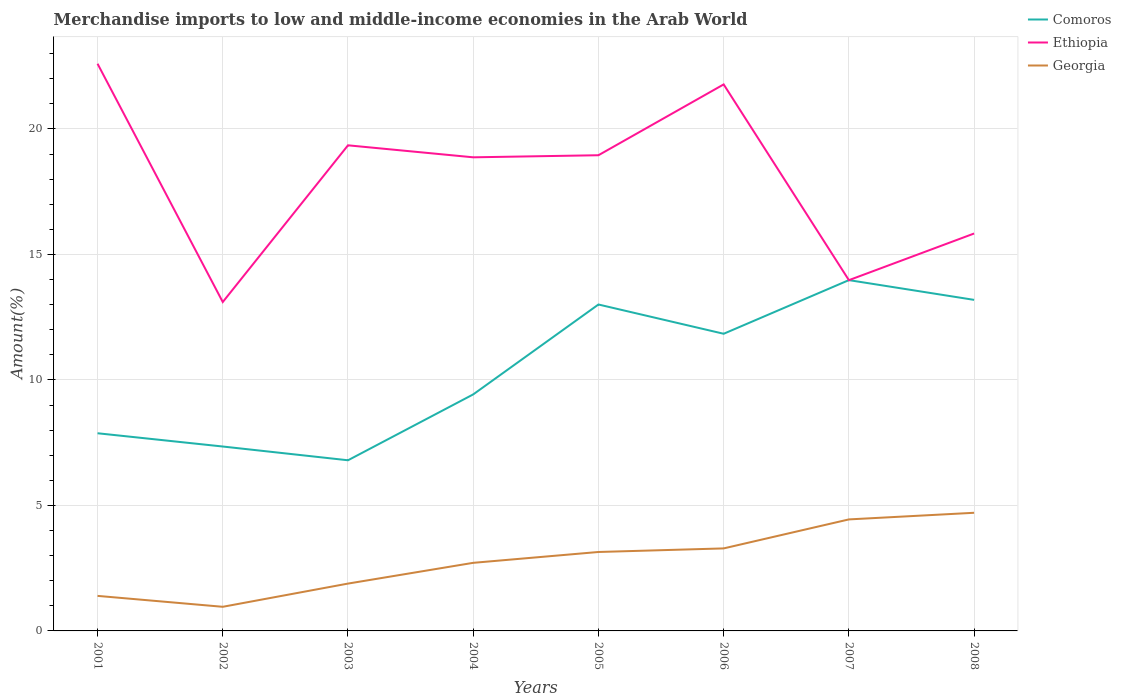How many different coloured lines are there?
Provide a succinct answer. 3. Does the line corresponding to Ethiopia intersect with the line corresponding to Comoros?
Your answer should be very brief. Yes. Across all years, what is the maximum percentage of amount earned from merchandise imports in Comoros?
Your answer should be compact. 6.8. In which year was the percentage of amount earned from merchandise imports in Ethiopia maximum?
Your answer should be very brief. 2002. What is the total percentage of amount earned from merchandise imports in Comoros in the graph?
Your response must be concise. -5.13. What is the difference between the highest and the second highest percentage of amount earned from merchandise imports in Ethiopia?
Keep it short and to the point. 9.49. What is the difference between the highest and the lowest percentage of amount earned from merchandise imports in Comoros?
Your response must be concise. 4. Is the percentage of amount earned from merchandise imports in Ethiopia strictly greater than the percentage of amount earned from merchandise imports in Georgia over the years?
Offer a terse response. No. Are the values on the major ticks of Y-axis written in scientific E-notation?
Your answer should be compact. No. Does the graph contain any zero values?
Your answer should be very brief. No. How many legend labels are there?
Your answer should be compact. 3. How are the legend labels stacked?
Offer a terse response. Vertical. What is the title of the graph?
Offer a terse response. Merchandise imports to low and middle-income economies in the Arab World. Does "Antigua and Barbuda" appear as one of the legend labels in the graph?
Provide a succinct answer. No. What is the label or title of the Y-axis?
Your answer should be compact. Amount(%). What is the Amount(%) of Comoros in 2001?
Your answer should be compact. 7.88. What is the Amount(%) in Ethiopia in 2001?
Give a very brief answer. 22.6. What is the Amount(%) in Georgia in 2001?
Ensure brevity in your answer.  1.4. What is the Amount(%) in Comoros in 2002?
Your answer should be very brief. 7.35. What is the Amount(%) of Ethiopia in 2002?
Give a very brief answer. 13.1. What is the Amount(%) in Georgia in 2002?
Your answer should be compact. 0.96. What is the Amount(%) of Comoros in 2003?
Keep it short and to the point. 6.8. What is the Amount(%) of Ethiopia in 2003?
Your answer should be very brief. 19.35. What is the Amount(%) of Georgia in 2003?
Offer a very short reply. 1.89. What is the Amount(%) in Comoros in 2004?
Keep it short and to the point. 9.42. What is the Amount(%) in Ethiopia in 2004?
Offer a terse response. 18.87. What is the Amount(%) in Georgia in 2004?
Keep it short and to the point. 2.71. What is the Amount(%) of Comoros in 2005?
Offer a very short reply. 13.01. What is the Amount(%) of Ethiopia in 2005?
Your answer should be very brief. 18.95. What is the Amount(%) in Georgia in 2005?
Offer a terse response. 3.15. What is the Amount(%) of Comoros in 2006?
Make the answer very short. 11.84. What is the Amount(%) in Ethiopia in 2006?
Your answer should be compact. 21.77. What is the Amount(%) of Georgia in 2006?
Provide a short and direct response. 3.29. What is the Amount(%) of Comoros in 2007?
Provide a short and direct response. 13.98. What is the Amount(%) in Ethiopia in 2007?
Your answer should be very brief. 13.98. What is the Amount(%) in Georgia in 2007?
Your response must be concise. 4.44. What is the Amount(%) of Comoros in 2008?
Provide a succinct answer. 13.19. What is the Amount(%) in Ethiopia in 2008?
Ensure brevity in your answer.  15.83. What is the Amount(%) of Georgia in 2008?
Offer a terse response. 4.71. Across all years, what is the maximum Amount(%) in Comoros?
Offer a terse response. 13.98. Across all years, what is the maximum Amount(%) in Ethiopia?
Your answer should be very brief. 22.6. Across all years, what is the maximum Amount(%) in Georgia?
Provide a succinct answer. 4.71. Across all years, what is the minimum Amount(%) of Comoros?
Make the answer very short. 6.8. Across all years, what is the minimum Amount(%) of Ethiopia?
Your response must be concise. 13.1. Across all years, what is the minimum Amount(%) of Georgia?
Your response must be concise. 0.96. What is the total Amount(%) in Comoros in the graph?
Provide a succinct answer. 83.46. What is the total Amount(%) in Ethiopia in the graph?
Provide a short and direct response. 144.46. What is the total Amount(%) in Georgia in the graph?
Your answer should be very brief. 22.54. What is the difference between the Amount(%) in Comoros in 2001 and that in 2002?
Ensure brevity in your answer.  0.53. What is the difference between the Amount(%) in Ethiopia in 2001 and that in 2002?
Give a very brief answer. 9.49. What is the difference between the Amount(%) of Georgia in 2001 and that in 2002?
Provide a short and direct response. 0.43. What is the difference between the Amount(%) in Comoros in 2001 and that in 2003?
Make the answer very short. 1.08. What is the difference between the Amount(%) of Ethiopia in 2001 and that in 2003?
Provide a short and direct response. 3.25. What is the difference between the Amount(%) in Georgia in 2001 and that in 2003?
Make the answer very short. -0.49. What is the difference between the Amount(%) in Comoros in 2001 and that in 2004?
Offer a terse response. -1.55. What is the difference between the Amount(%) in Ethiopia in 2001 and that in 2004?
Ensure brevity in your answer.  3.73. What is the difference between the Amount(%) of Georgia in 2001 and that in 2004?
Provide a short and direct response. -1.32. What is the difference between the Amount(%) of Comoros in 2001 and that in 2005?
Make the answer very short. -5.13. What is the difference between the Amount(%) in Ethiopia in 2001 and that in 2005?
Offer a terse response. 3.65. What is the difference between the Amount(%) in Georgia in 2001 and that in 2005?
Your response must be concise. -1.75. What is the difference between the Amount(%) of Comoros in 2001 and that in 2006?
Keep it short and to the point. -3.96. What is the difference between the Amount(%) of Ethiopia in 2001 and that in 2006?
Give a very brief answer. 0.82. What is the difference between the Amount(%) of Georgia in 2001 and that in 2006?
Make the answer very short. -1.89. What is the difference between the Amount(%) in Comoros in 2001 and that in 2007?
Your answer should be very brief. -6.1. What is the difference between the Amount(%) of Ethiopia in 2001 and that in 2007?
Ensure brevity in your answer.  8.62. What is the difference between the Amount(%) in Georgia in 2001 and that in 2007?
Ensure brevity in your answer.  -3.05. What is the difference between the Amount(%) in Comoros in 2001 and that in 2008?
Give a very brief answer. -5.31. What is the difference between the Amount(%) of Ethiopia in 2001 and that in 2008?
Your answer should be compact. 6.76. What is the difference between the Amount(%) in Georgia in 2001 and that in 2008?
Give a very brief answer. -3.31. What is the difference between the Amount(%) of Comoros in 2002 and that in 2003?
Keep it short and to the point. 0.55. What is the difference between the Amount(%) of Ethiopia in 2002 and that in 2003?
Your response must be concise. -6.24. What is the difference between the Amount(%) in Georgia in 2002 and that in 2003?
Provide a short and direct response. -0.93. What is the difference between the Amount(%) of Comoros in 2002 and that in 2004?
Provide a short and direct response. -2.08. What is the difference between the Amount(%) in Ethiopia in 2002 and that in 2004?
Give a very brief answer. -5.77. What is the difference between the Amount(%) in Georgia in 2002 and that in 2004?
Your response must be concise. -1.75. What is the difference between the Amount(%) in Comoros in 2002 and that in 2005?
Give a very brief answer. -5.66. What is the difference between the Amount(%) in Ethiopia in 2002 and that in 2005?
Offer a very short reply. -5.85. What is the difference between the Amount(%) in Georgia in 2002 and that in 2005?
Keep it short and to the point. -2.18. What is the difference between the Amount(%) of Comoros in 2002 and that in 2006?
Your response must be concise. -4.49. What is the difference between the Amount(%) of Ethiopia in 2002 and that in 2006?
Ensure brevity in your answer.  -8.67. What is the difference between the Amount(%) in Georgia in 2002 and that in 2006?
Offer a very short reply. -2.33. What is the difference between the Amount(%) of Comoros in 2002 and that in 2007?
Ensure brevity in your answer.  -6.63. What is the difference between the Amount(%) in Ethiopia in 2002 and that in 2007?
Make the answer very short. -0.87. What is the difference between the Amount(%) of Georgia in 2002 and that in 2007?
Offer a terse response. -3.48. What is the difference between the Amount(%) of Comoros in 2002 and that in 2008?
Provide a short and direct response. -5.84. What is the difference between the Amount(%) in Ethiopia in 2002 and that in 2008?
Offer a very short reply. -2.73. What is the difference between the Amount(%) in Georgia in 2002 and that in 2008?
Offer a terse response. -3.75. What is the difference between the Amount(%) of Comoros in 2003 and that in 2004?
Ensure brevity in your answer.  -2.62. What is the difference between the Amount(%) of Ethiopia in 2003 and that in 2004?
Your answer should be very brief. 0.48. What is the difference between the Amount(%) of Georgia in 2003 and that in 2004?
Keep it short and to the point. -0.83. What is the difference between the Amount(%) of Comoros in 2003 and that in 2005?
Provide a succinct answer. -6.21. What is the difference between the Amount(%) of Ethiopia in 2003 and that in 2005?
Offer a very short reply. 0.4. What is the difference between the Amount(%) of Georgia in 2003 and that in 2005?
Keep it short and to the point. -1.26. What is the difference between the Amount(%) of Comoros in 2003 and that in 2006?
Provide a short and direct response. -5.04. What is the difference between the Amount(%) in Ethiopia in 2003 and that in 2006?
Make the answer very short. -2.43. What is the difference between the Amount(%) in Georgia in 2003 and that in 2006?
Provide a short and direct response. -1.4. What is the difference between the Amount(%) in Comoros in 2003 and that in 2007?
Provide a succinct answer. -7.18. What is the difference between the Amount(%) in Ethiopia in 2003 and that in 2007?
Offer a terse response. 5.37. What is the difference between the Amount(%) in Georgia in 2003 and that in 2007?
Your answer should be very brief. -2.56. What is the difference between the Amount(%) of Comoros in 2003 and that in 2008?
Your response must be concise. -6.39. What is the difference between the Amount(%) of Ethiopia in 2003 and that in 2008?
Provide a short and direct response. 3.51. What is the difference between the Amount(%) of Georgia in 2003 and that in 2008?
Provide a succinct answer. -2.82. What is the difference between the Amount(%) in Comoros in 2004 and that in 2005?
Offer a very short reply. -3.58. What is the difference between the Amount(%) of Ethiopia in 2004 and that in 2005?
Make the answer very short. -0.08. What is the difference between the Amount(%) of Georgia in 2004 and that in 2005?
Ensure brevity in your answer.  -0.43. What is the difference between the Amount(%) of Comoros in 2004 and that in 2006?
Ensure brevity in your answer.  -2.42. What is the difference between the Amount(%) in Ethiopia in 2004 and that in 2006?
Your answer should be compact. -2.9. What is the difference between the Amount(%) of Georgia in 2004 and that in 2006?
Offer a very short reply. -0.57. What is the difference between the Amount(%) of Comoros in 2004 and that in 2007?
Provide a succinct answer. -4.55. What is the difference between the Amount(%) in Ethiopia in 2004 and that in 2007?
Provide a succinct answer. 4.89. What is the difference between the Amount(%) of Georgia in 2004 and that in 2007?
Give a very brief answer. -1.73. What is the difference between the Amount(%) of Comoros in 2004 and that in 2008?
Your answer should be very brief. -3.77. What is the difference between the Amount(%) in Ethiopia in 2004 and that in 2008?
Offer a very short reply. 3.04. What is the difference between the Amount(%) in Georgia in 2004 and that in 2008?
Your answer should be very brief. -1.99. What is the difference between the Amount(%) in Comoros in 2005 and that in 2006?
Provide a succinct answer. 1.17. What is the difference between the Amount(%) of Ethiopia in 2005 and that in 2006?
Your response must be concise. -2.82. What is the difference between the Amount(%) of Georgia in 2005 and that in 2006?
Your answer should be compact. -0.14. What is the difference between the Amount(%) in Comoros in 2005 and that in 2007?
Offer a terse response. -0.97. What is the difference between the Amount(%) in Ethiopia in 2005 and that in 2007?
Ensure brevity in your answer.  4.98. What is the difference between the Amount(%) in Georgia in 2005 and that in 2007?
Provide a short and direct response. -1.3. What is the difference between the Amount(%) of Comoros in 2005 and that in 2008?
Make the answer very short. -0.18. What is the difference between the Amount(%) of Ethiopia in 2005 and that in 2008?
Provide a short and direct response. 3.12. What is the difference between the Amount(%) of Georgia in 2005 and that in 2008?
Give a very brief answer. -1.56. What is the difference between the Amount(%) in Comoros in 2006 and that in 2007?
Keep it short and to the point. -2.14. What is the difference between the Amount(%) in Ethiopia in 2006 and that in 2007?
Offer a very short reply. 7.8. What is the difference between the Amount(%) of Georgia in 2006 and that in 2007?
Provide a short and direct response. -1.16. What is the difference between the Amount(%) of Comoros in 2006 and that in 2008?
Your answer should be compact. -1.35. What is the difference between the Amount(%) of Ethiopia in 2006 and that in 2008?
Your answer should be very brief. 5.94. What is the difference between the Amount(%) in Georgia in 2006 and that in 2008?
Your answer should be very brief. -1.42. What is the difference between the Amount(%) in Comoros in 2007 and that in 2008?
Ensure brevity in your answer.  0.79. What is the difference between the Amount(%) of Ethiopia in 2007 and that in 2008?
Your answer should be compact. -1.86. What is the difference between the Amount(%) of Georgia in 2007 and that in 2008?
Ensure brevity in your answer.  -0.26. What is the difference between the Amount(%) in Comoros in 2001 and the Amount(%) in Ethiopia in 2002?
Provide a short and direct response. -5.23. What is the difference between the Amount(%) in Comoros in 2001 and the Amount(%) in Georgia in 2002?
Provide a succinct answer. 6.91. What is the difference between the Amount(%) of Ethiopia in 2001 and the Amount(%) of Georgia in 2002?
Your answer should be compact. 21.64. What is the difference between the Amount(%) of Comoros in 2001 and the Amount(%) of Ethiopia in 2003?
Keep it short and to the point. -11.47. What is the difference between the Amount(%) in Comoros in 2001 and the Amount(%) in Georgia in 2003?
Ensure brevity in your answer.  5.99. What is the difference between the Amount(%) of Ethiopia in 2001 and the Amount(%) of Georgia in 2003?
Provide a succinct answer. 20.71. What is the difference between the Amount(%) in Comoros in 2001 and the Amount(%) in Ethiopia in 2004?
Keep it short and to the point. -10.99. What is the difference between the Amount(%) in Comoros in 2001 and the Amount(%) in Georgia in 2004?
Offer a very short reply. 5.16. What is the difference between the Amount(%) in Ethiopia in 2001 and the Amount(%) in Georgia in 2004?
Give a very brief answer. 19.89. What is the difference between the Amount(%) in Comoros in 2001 and the Amount(%) in Ethiopia in 2005?
Keep it short and to the point. -11.08. What is the difference between the Amount(%) in Comoros in 2001 and the Amount(%) in Georgia in 2005?
Provide a succinct answer. 4.73. What is the difference between the Amount(%) of Ethiopia in 2001 and the Amount(%) of Georgia in 2005?
Offer a terse response. 19.45. What is the difference between the Amount(%) in Comoros in 2001 and the Amount(%) in Ethiopia in 2006?
Your response must be concise. -13.9. What is the difference between the Amount(%) in Comoros in 2001 and the Amount(%) in Georgia in 2006?
Provide a short and direct response. 4.59. What is the difference between the Amount(%) of Ethiopia in 2001 and the Amount(%) of Georgia in 2006?
Your answer should be very brief. 19.31. What is the difference between the Amount(%) of Comoros in 2001 and the Amount(%) of Ethiopia in 2007?
Offer a very short reply. -6.1. What is the difference between the Amount(%) of Comoros in 2001 and the Amount(%) of Georgia in 2007?
Your answer should be compact. 3.43. What is the difference between the Amount(%) in Ethiopia in 2001 and the Amount(%) in Georgia in 2007?
Keep it short and to the point. 18.16. What is the difference between the Amount(%) of Comoros in 2001 and the Amount(%) of Ethiopia in 2008?
Your answer should be compact. -7.96. What is the difference between the Amount(%) in Comoros in 2001 and the Amount(%) in Georgia in 2008?
Offer a very short reply. 3.17. What is the difference between the Amount(%) of Ethiopia in 2001 and the Amount(%) of Georgia in 2008?
Provide a succinct answer. 17.89. What is the difference between the Amount(%) of Comoros in 2002 and the Amount(%) of Ethiopia in 2003?
Provide a succinct answer. -12. What is the difference between the Amount(%) in Comoros in 2002 and the Amount(%) in Georgia in 2003?
Give a very brief answer. 5.46. What is the difference between the Amount(%) of Ethiopia in 2002 and the Amount(%) of Georgia in 2003?
Your answer should be very brief. 11.22. What is the difference between the Amount(%) of Comoros in 2002 and the Amount(%) of Ethiopia in 2004?
Provide a succinct answer. -11.52. What is the difference between the Amount(%) of Comoros in 2002 and the Amount(%) of Georgia in 2004?
Your answer should be very brief. 4.63. What is the difference between the Amount(%) of Ethiopia in 2002 and the Amount(%) of Georgia in 2004?
Offer a very short reply. 10.39. What is the difference between the Amount(%) in Comoros in 2002 and the Amount(%) in Ethiopia in 2005?
Give a very brief answer. -11.61. What is the difference between the Amount(%) in Comoros in 2002 and the Amount(%) in Georgia in 2005?
Your response must be concise. 4.2. What is the difference between the Amount(%) of Ethiopia in 2002 and the Amount(%) of Georgia in 2005?
Offer a terse response. 9.96. What is the difference between the Amount(%) in Comoros in 2002 and the Amount(%) in Ethiopia in 2006?
Provide a succinct answer. -14.43. What is the difference between the Amount(%) in Comoros in 2002 and the Amount(%) in Georgia in 2006?
Your response must be concise. 4.06. What is the difference between the Amount(%) in Ethiopia in 2002 and the Amount(%) in Georgia in 2006?
Give a very brief answer. 9.82. What is the difference between the Amount(%) of Comoros in 2002 and the Amount(%) of Ethiopia in 2007?
Make the answer very short. -6.63. What is the difference between the Amount(%) of Comoros in 2002 and the Amount(%) of Georgia in 2007?
Make the answer very short. 2.9. What is the difference between the Amount(%) of Ethiopia in 2002 and the Amount(%) of Georgia in 2007?
Offer a very short reply. 8.66. What is the difference between the Amount(%) of Comoros in 2002 and the Amount(%) of Ethiopia in 2008?
Offer a very short reply. -8.49. What is the difference between the Amount(%) in Comoros in 2002 and the Amount(%) in Georgia in 2008?
Your answer should be very brief. 2.64. What is the difference between the Amount(%) of Ethiopia in 2002 and the Amount(%) of Georgia in 2008?
Offer a terse response. 8.4. What is the difference between the Amount(%) in Comoros in 2003 and the Amount(%) in Ethiopia in 2004?
Provide a succinct answer. -12.07. What is the difference between the Amount(%) in Comoros in 2003 and the Amount(%) in Georgia in 2004?
Your response must be concise. 4.09. What is the difference between the Amount(%) of Ethiopia in 2003 and the Amount(%) of Georgia in 2004?
Ensure brevity in your answer.  16.64. What is the difference between the Amount(%) of Comoros in 2003 and the Amount(%) of Ethiopia in 2005?
Offer a very short reply. -12.15. What is the difference between the Amount(%) of Comoros in 2003 and the Amount(%) of Georgia in 2005?
Give a very brief answer. 3.65. What is the difference between the Amount(%) of Ethiopia in 2003 and the Amount(%) of Georgia in 2005?
Keep it short and to the point. 16.2. What is the difference between the Amount(%) in Comoros in 2003 and the Amount(%) in Ethiopia in 2006?
Provide a short and direct response. -14.98. What is the difference between the Amount(%) of Comoros in 2003 and the Amount(%) of Georgia in 2006?
Keep it short and to the point. 3.51. What is the difference between the Amount(%) in Ethiopia in 2003 and the Amount(%) in Georgia in 2006?
Your answer should be compact. 16.06. What is the difference between the Amount(%) of Comoros in 2003 and the Amount(%) of Ethiopia in 2007?
Offer a terse response. -7.18. What is the difference between the Amount(%) in Comoros in 2003 and the Amount(%) in Georgia in 2007?
Make the answer very short. 2.36. What is the difference between the Amount(%) of Ethiopia in 2003 and the Amount(%) of Georgia in 2007?
Offer a terse response. 14.91. What is the difference between the Amount(%) in Comoros in 2003 and the Amount(%) in Ethiopia in 2008?
Provide a short and direct response. -9.04. What is the difference between the Amount(%) of Comoros in 2003 and the Amount(%) of Georgia in 2008?
Provide a short and direct response. 2.09. What is the difference between the Amount(%) in Ethiopia in 2003 and the Amount(%) in Georgia in 2008?
Give a very brief answer. 14.64. What is the difference between the Amount(%) of Comoros in 2004 and the Amount(%) of Ethiopia in 2005?
Offer a terse response. -9.53. What is the difference between the Amount(%) of Comoros in 2004 and the Amount(%) of Georgia in 2005?
Keep it short and to the point. 6.28. What is the difference between the Amount(%) in Ethiopia in 2004 and the Amount(%) in Georgia in 2005?
Your answer should be very brief. 15.72. What is the difference between the Amount(%) in Comoros in 2004 and the Amount(%) in Ethiopia in 2006?
Provide a succinct answer. -12.35. What is the difference between the Amount(%) of Comoros in 2004 and the Amount(%) of Georgia in 2006?
Give a very brief answer. 6.14. What is the difference between the Amount(%) in Ethiopia in 2004 and the Amount(%) in Georgia in 2006?
Your answer should be very brief. 15.58. What is the difference between the Amount(%) in Comoros in 2004 and the Amount(%) in Ethiopia in 2007?
Provide a succinct answer. -4.55. What is the difference between the Amount(%) of Comoros in 2004 and the Amount(%) of Georgia in 2007?
Ensure brevity in your answer.  4.98. What is the difference between the Amount(%) of Ethiopia in 2004 and the Amount(%) of Georgia in 2007?
Your response must be concise. 14.43. What is the difference between the Amount(%) of Comoros in 2004 and the Amount(%) of Ethiopia in 2008?
Your answer should be compact. -6.41. What is the difference between the Amount(%) in Comoros in 2004 and the Amount(%) in Georgia in 2008?
Your response must be concise. 4.72. What is the difference between the Amount(%) of Ethiopia in 2004 and the Amount(%) of Georgia in 2008?
Make the answer very short. 14.16. What is the difference between the Amount(%) in Comoros in 2005 and the Amount(%) in Ethiopia in 2006?
Your answer should be very brief. -8.77. What is the difference between the Amount(%) in Comoros in 2005 and the Amount(%) in Georgia in 2006?
Offer a terse response. 9.72. What is the difference between the Amount(%) of Ethiopia in 2005 and the Amount(%) of Georgia in 2006?
Keep it short and to the point. 15.67. What is the difference between the Amount(%) of Comoros in 2005 and the Amount(%) of Ethiopia in 2007?
Provide a succinct answer. -0.97. What is the difference between the Amount(%) of Comoros in 2005 and the Amount(%) of Georgia in 2007?
Give a very brief answer. 8.56. What is the difference between the Amount(%) in Ethiopia in 2005 and the Amount(%) in Georgia in 2007?
Give a very brief answer. 14.51. What is the difference between the Amount(%) of Comoros in 2005 and the Amount(%) of Ethiopia in 2008?
Your answer should be very brief. -2.83. What is the difference between the Amount(%) in Comoros in 2005 and the Amount(%) in Georgia in 2008?
Your response must be concise. 8.3. What is the difference between the Amount(%) of Ethiopia in 2005 and the Amount(%) of Georgia in 2008?
Your response must be concise. 14.25. What is the difference between the Amount(%) in Comoros in 2006 and the Amount(%) in Ethiopia in 2007?
Offer a very short reply. -2.14. What is the difference between the Amount(%) in Comoros in 2006 and the Amount(%) in Georgia in 2007?
Make the answer very short. 7.4. What is the difference between the Amount(%) of Ethiopia in 2006 and the Amount(%) of Georgia in 2007?
Offer a very short reply. 17.33. What is the difference between the Amount(%) in Comoros in 2006 and the Amount(%) in Ethiopia in 2008?
Ensure brevity in your answer.  -3.99. What is the difference between the Amount(%) of Comoros in 2006 and the Amount(%) of Georgia in 2008?
Make the answer very short. 7.13. What is the difference between the Amount(%) of Ethiopia in 2006 and the Amount(%) of Georgia in 2008?
Your response must be concise. 17.07. What is the difference between the Amount(%) of Comoros in 2007 and the Amount(%) of Ethiopia in 2008?
Make the answer very short. -1.86. What is the difference between the Amount(%) of Comoros in 2007 and the Amount(%) of Georgia in 2008?
Keep it short and to the point. 9.27. What is the difference between the Amount(%) of Ethiopia in 2007 and the Amount(%) of Georgia in 2008?
Provide a succinct answer. 9.27. What is the average Amount(%) in Comoros per year?
Your answer should be compact. 10.43. What is the average Amount(%) of Ethiopia per year?
Give a very brief answer. 18.06. What is the average Amount(%) in Georgia per year?
Keep it short and to the point. 2.82. In the year 2001, what is the difference between the Amount(%) in Comoros and Amount(%) in Ethiopia?
Offer a very short reply. -14.72. In the year 2001, what is the difference between the Amount(%) in Comoros and Amount(%) in Georgia?
Your answer should be compact. 6.48. In the year 2001, what is the difference between the Amount(%) of Ethiopia and Amount(%) of Georgia?
Make the answer very short. 21.2. In the year 2002, what is the difference between the Amount(%) of Comoros and Amount(%) of Ethiopia?
Offer a very short reply. -5.76. In the year 2002, what is the difference between the Amount(%) of Comoros and Amount(%) of Georgia?
Provide a succinct answer. 6.39. In the year 2002, what is the difference between the Amount(%) of Ethiopia and Amount(%) of Georgia?
Provide a succinct answer. 12.14. In the year 2003, what is the difference between the Amount(%) of Comoros and Amount(%) of Ethiopia?
Provide a succinct answer. -12.55. In the year 2003, what is the difference between the Amount(%) of Comoros and Amount(%) of Georgia?
Make the answer very short. 4.91. In the year 2003, what is the difference between the Amount(%) of Ethiopia and Amount(%) of Georgia?
Provide a succinct answer. 17.46. In the year 2004, what is the difference between the Amount(%) of Comoros and Amount(%) of Ethiopia?
Ensure brevity in your answer.  -9.45. In the year 2004, what is the difference between the Amount(%) of Comoros and Amount(%) of Georgia?
Keep it short and to the point. 6.71. In the year 2004, what is the difference between the Amount(%) of Ethiopia and Amount(%) of Georgia?
Provide a succinct answer. 16.16. In the year 2005, what is the difference between the Amount(%) of Comoros and Amount(%) of Ethiopia?
Offer a very short reply. -5.95. In the year 2005, what is the difference between the Amount(%) in Comoros and Amount(%) in Georgia?
Give a very brief answer. 9.86. In the year 2005, what is the difference between the Amount(%) of Ethiopia and Amount(%) of Georgia?
Offer a very short reply. 15.81. In the year 2006, what is the difference between the Amount(%) in Comoros and Amount(%) in Ethiopia?
Provide a short and direct response. -9.94. In the year 2006, what is the difference between the Amount(%) of Comoros and Amount(%) of Georgia?
Ensure brevity in your answer.  8.55. In the year 2006, what is the difference between the Amount(%) of Ethiopia and Amount(%) of Georgia?
Your answer should be compact. 18.49. In the year 2007, what is the difference between the Amount(%) in Comoros and Amount(%) in Ethiopia?
Your response must be concise. 0. In the year 2007, what is the difference between the Amount(%) in Comoros and Amount(%) in Georgia?
Your response must be concise. 9.53. In the year 2007, what is the difference between the Amount(%) in Ethiopia and Amount(%) in Georgia?
Your response must be concise. 9.53. In the year 2008, what is the difference between the Amount(%) in Comoros and Amount(%) in Ethiopia?
Offer a terse response. -2.64. In the year 2008, what is the difference between the Amount(%) of Comoros and Amount(%) of Georgia?
Ensure brevity in your answer.  8.48. In the year 2008, what is the difference between the Amount(%) of Ethiopia and Amount(%) of Georgia?
Make the answer very short. 11.13. What is the ratio of the Amount(%) of Comoros in 2001 to that in 2002?
Provide a short and direct response. 1.07. What is the ratio of the Amount(%) of Ethiopia in 2001 to that in 2002?
Your answer should be compact. 1.72. What is the ratio of the Amount(%) of Georgia in 2001 to that in 2002?
Give a very brief answer. 1.45. What is the ratio of the Amount(%) in Comoros in 2001 to that in 2003?
Make the answer very short. 1.16. What is the ratio of the Amount(%) of Ethiopia in 2001 to that in 2003?
Provide a succinct answer. 1.17. What is the ratio of the Amount(%) in Georgia in 2001 to that in 2003?
Your answer should be very brief. 0.74. What is the ratio of the Amount(%) of Comoros in 2001 to that in 2004?
Provide a short and direct response. 0.84. What is the ratio of the Amount(%) in Ethiopia in 2001 to that in 2004?
Give a very brief answer. 1.2. What is the ratio of the Amount(%) in Georgia in 2001 to that in 2004?
Give a very brief answer. 0.51. What is the ratio of the Amount(%) of Comoros in 2001 to that in 2005?
Offer a terse response. 0.61. What is the ratio of the Amount(%) of Ethiopia in 2001 to that in 2005?
Offer a very short reply. 1.19. What is the ratio of the Amount(%) of Georgia in 2001 to that in 2005?
Ensure brevity in your answer.  0.44. What is the ratio of the Amount(%) of Comoros in 2001 to that in 2006?
Your answer should be compact. 0.67. What is the ratio of the Amount(%) in Ethiopia in 2001 to that in 2006?
Provide a short and direct response. 1.04. What is the ratio of the Amount(%) of Georgia in 2001 to that in 2006?
Your response must be concise. 0.42. What is the ratio of the Amount(%) in Comoros in 2001 to that in 2007?
Your answer should be compact. 0.56. What is the ratio of the Amount(%) in Ethiopia in 2001 to that in 2007?
Keep it short and to the point. 1.62. What is the ratio of the Amount(%) in Georgia in 2001 to that in 2007?
Your response must be concise. 0.31. What is the ratio of the Amount(%) of Comoros in 2001 to that in 2008?
Offer a very short reply. 0.6. What is the ratio of the Amount(%) of Ethiopia in 2001 to that in 2008?
Give a very brief answer. 1.43. What is the ratio of the Amount(%) of Georgia in 2001 to that in 2008?
Offer a very short reply. 0.3. What is the ratio of the Amount(%) of Comoros in 2002 to that in 2003?
Your answer should be compact. 1.08. What is the ratio of the Amount(%) in Ethiopia in 2002 to that in 2003?
Your answer should be very brief. 0.68. What is the ratio of the Amount(%) of Georgia in 2002 to that in 2003?
Provide a short and direct response. 0.51. What is the ratio of the Amount(%) in Comoros in 2002 to that in 2004?
Your response must be concise. 0.78. What is the ratio of the Amount(%) in Ethiopia in 2002 to that in 2004?
Keep it short and to the point. 0.69. What is the ratio of the Amount(%) in Georgia in 2002 to that in 2004?
Offer a terse response. 0.35. What is the ratio of the Amount(%) of Comoros in 2002 to that in 2005?
Make the answer very short. 0.56. What is the ratio of the Amount(%) of Ethiopia in 2002 to that in 2005?
Make the answer very short. 0.69. What is the ratio of the Amount(%) of Georgia in 2002 to that in 2005?
Your response must be concise. 0.31. What is the ratio of the Amount(%) in Comoros in 2002 to that in 2006?
Your response must be concise. 0.62. What is the ratio of the Amount(%) of Ethiopia in 2002 to that in 2006?
Give a very brief answer. 0.6. What is the ratio of the Amount(%) of Georgia in 2002 to that in 2006?
Offer a very short reply. 0.29. What is the ratio of the Amount(%) of Comoros in 2002 to that in 2007?
Offer a very short reply. 0.53. What is the ratio of the Amount(%) in Ethiopia in 2002 to that in 2007?
Offer a terse response. 0.94. What is the ratio of the Amount(%) in Georgia in 2002 to that in 2007?
Your answer should be compact. 0.22. What is the ratio of the Amount(%) in Comoros in 2002 to that in 2008?
Make the answer very short. 0.56. What is the ratio of the Amount(%) of Ethiopia in 2002 to that in 2008?
Your answer should be very brief. 0.83. What is the ratio of the Amount(%) in Georgia in 2002 to that in 2008?
Ensure brevity in your answer.  0.2. What is the ratio of the Amount(%) in Comoros in 2003 to that in 2004?
Your response must be concise. 0.72. What is the ratio of the Amount(%) of Ethiopia in 2003 to that in 2004?
Your response must be concise. 1.03. What is the ratio of the Amount(%) in Georgia in 2003 to that in 2004?
Offer a terse response. 0.7. What is the ratio of the Amount(%) in Comoros in 2003 to that in 2005?
Your response must be concise. 0.52. What is the ratio of the Amount(%) of Ethiopia in 2003 to that in 2005?
Your answer should be compact. 1.02. What is the ratio of the Amount(%) of Georgia in 2003 to that in 2005?
Offer a terse response. 0.6. What is the ratio of the Amount(%) of Comoros in 2003 to that in 2006?
Your answer should be very brief. 0.57. What is the ratio of the Amount(%) in Ethiopia in 2003 to that in 2006?
Keep it short and to the point. 0.89. What is the ratio of the Amount(%) in Georgia in 2003 to that in 2006?
Ensure brevity in your answer.  0.57. What is the ratio of the Amount(%) of Comoros in 2003 to that in 2007?
Your answer should be very brief. 0.49. What is the ratio of the Amount(%) in Ethiopia in 2003 to that in 2007?
Offer a very short reply. 1.38. What is the ratio of the Amount(%) in Georgia in 2003 to that in 2007?
Give a very brief answer. 0.42. What is the ratio of the Amount(%) in Comoros in 2003 to that in 2008?
Give a very brief answer. 0.52. What is the ratio of the Amount(%) of Ethiopia in 2003 to that in 2008?
Provide a short and direct response. 1.22. What is the ratio of the Amount(%) in Georgia in 2003 to that in 2008?
Your response must be concise. 0.4. What is the ratio of the Amount(%) in Comoros in 2004 to that in 2005?
Provide a short and direct response. 0.72. What is the ratio of the Amount(%) in Ethiopia in 2004 to that in 2005?
Provide a succinct answer. 1. What is the ratio of the Amount(%) in Georgia in 2004 to that in 2005?
Provide a short and direct response. 0.86. What is the ratio of the Amount(%) of Comoros in 2004 to that in 2006?
Provide a short and direct response. 0.8. What is the ratio of the Amount(%) in Ethiopia in 2004 to that in 2006?
Give a very brief answer. 0.87. What is the ratio of the Amount(%) in Georgia in 2004 to that in 2006?
Your response must be concise. 0.83. What is the ratio of the Amount(%) in Comoros in 2004 to that in 2007?
Ensure brevity in your answer.  0.67. What is the ratio of the Amount(%) of Ethiopia in 2004 to that in 2007?
Offer a terse response. 1.35. What is the ratio of the Amount(%) of Georgia in 2004 to that in 2007?
Make the answer very short. 0.61. What is the ratio of the Amount(%) in Comoros in 2004 to that in 2008?
Your response must be concise. 0.71. What is the ratio of the Amount(%) of Ethiopia in 2004 to that in 2008?
Your answer should be very brief. 1.19. What is the ratio of the Amount(%) of Georgia in 2004 to that in 2008?
Provide a short and direct response. 0.58. What is the ratio of the Amount(%) in Comoros in 2005 to that in 2006?
Your answer should be compact. 1.1. What is the ratio of the Amount(%) in Ethiopia in 2005 to that in 2006?
Make the answer very short. 0.87. What is the ratio of the Amount(%) in Georgia in 2005 to that in 2006?
Ensure brevity in your answer.  0.96. What is the ratio of the Amount(%) of Comoros in 2005 to that in 2007?
Your answer should be compact. 0.93. What is the ratio of the Amount(%) in Ethiopia in 2005 to that in 2007?
Offer a terse response. 1.36. What is the ratio of the Amount(%) in Georgia in 2005 to that in 2007?
Your response must be concise. 0.71. What is the ratio of the Amount(%) in Ethiopia in 2005 to that in 2008?
Your answer should be very brief. 1.2. What is the ratio of the Amount(%) in Georgia in 2005 to that in 2008?
Offer a terse response. 0.67. What is the ratio of the Amount(%) of Comoros in 2006 to that in 2007?
Make the answer very short. 0.85. What is the ratio of the Amount(%) in Ethiopia in 2006 to that in 2007?
Your answer should be very brief. 1.56. What is the ratio of the Amount(%) in Georgia in 2006 to that in 2007?
Provide a succinct answer. 0.74. What is the ratio of the Amount(%) of Comoros in 2006 to that in 2008?
Ensure brevity in your answer.  0.9. What is the ratio of the Amount(%) in Ethiopia in 2006 to that in 2008?
Offer a terse response. 1.38. What is the ratio of the Amount(%) in Georgia in 2006 to that in 2008?
Your answer should be compact. 0.7. What is the ratio of the Amount(%) in Comoros in 2007 to that in 2008?
Make the answer very short. 1.06. What is the ratio of the Amount(%) in Ethiopia in 2007 to that in 2008?
Make the answer very short. 0.88. What is the ratio of the Amount(%) in Georgia in 2007 to that in 2008?
Offer a terse response. 0.94. What is the difference between the highest and the second highest Amount(%) of Comoros?
Your answer should be very brief. 0.79. What is the difference between the highest and the second highest Amount(%) of Ethiopia?
Keep it short and to the point. 0.82. What is the difference between the highest and the second highest Amount(%) in Georgia?
Offer a very short reply. 0.26. What is the difference between the highest and the lowest Amount(%) of Comoros?
Give a very brief answer. 7.18. What is the difference between the highest and the lowest Amount(%) of Ethiopia?
Your answer should be very brief. 9.49. What is the difference between the highest and the lowest Amount(%) in Georgia?
Give a very brief answer. 3.75. 